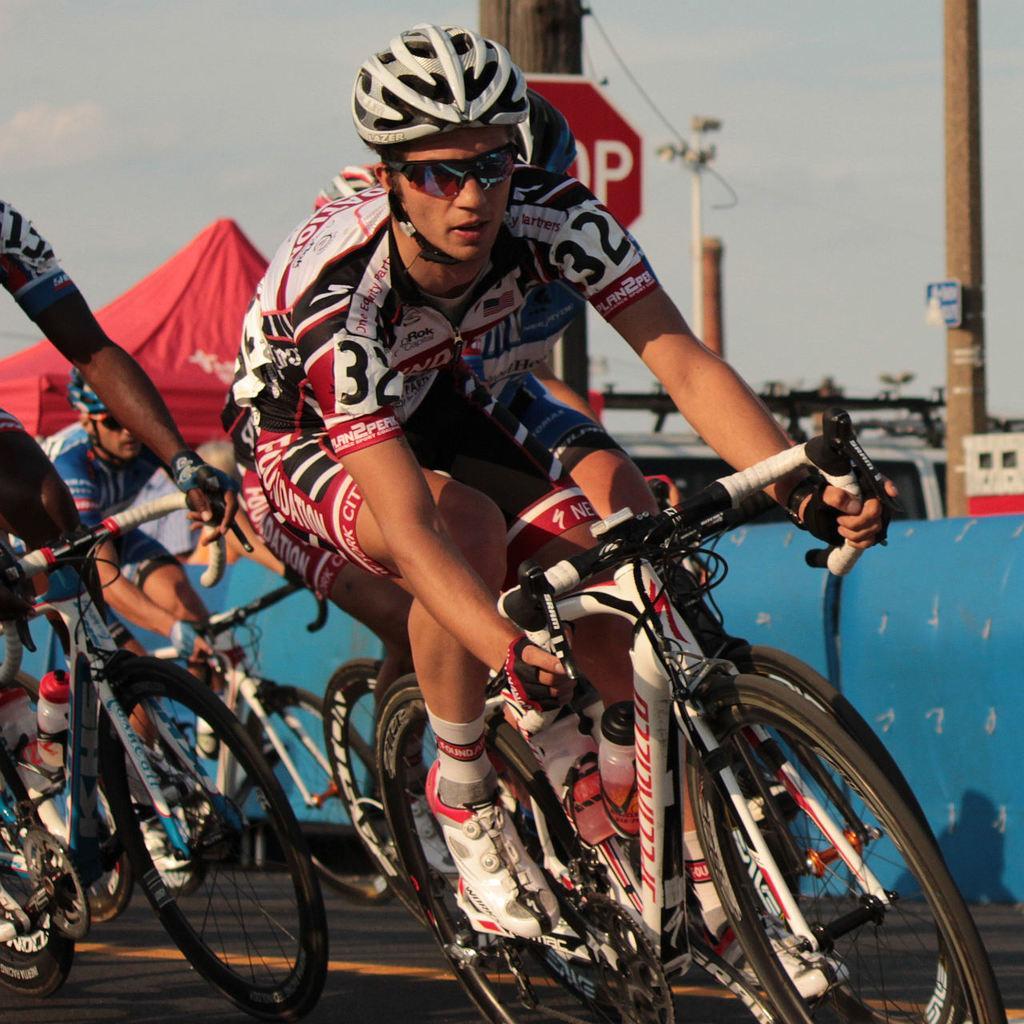In one or two sentences, can you explain what this image depicts? In this picture I can see few people riding bicycles and they wore helmets on their heads and sunglasses and I can see few poles and a tent and I can see a sign board to the pole and I can see a cloudy sky. 